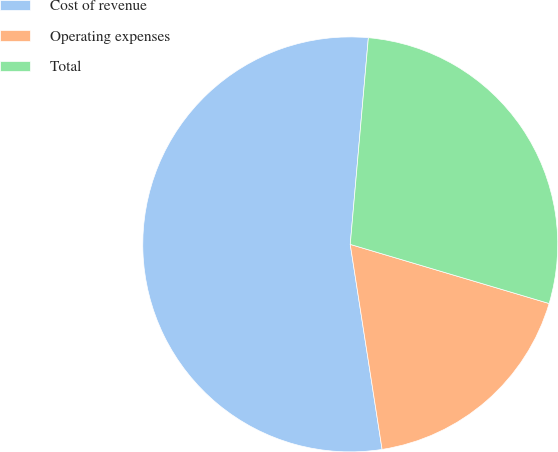Convert chart to OTSL. <chart><loc_0><loc_0><loc_500><loc_500><pie_chart><fcel>Cost of revenue<fcel>Operating expenses<fcel>Total<nl><fcel>53.85%<fcel>17.95%<fcel>28.21%<nl></chart> 